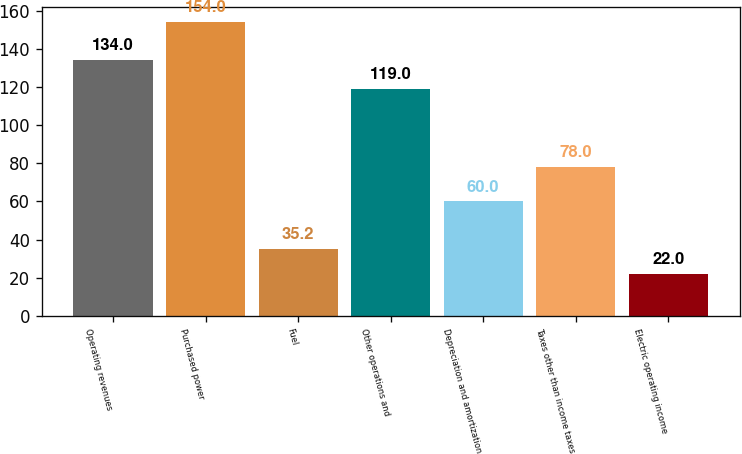Convert chart to OTSL. <chart><loc_0><loc_0><loc_500><loc_500><bar_chart><fcel>Operating revenues<fcel>Purchased power<fcel>Fuel<fcel>Other operations and<fcel>Depreciation and amortization<fcel>Taxes other than income taxes<fcel>Electric operating income<nl><fcel>134<fcel>154<fcel>35.2<fcel>119<fcel>60<fcel>78<fcel>22<nl></chart> 